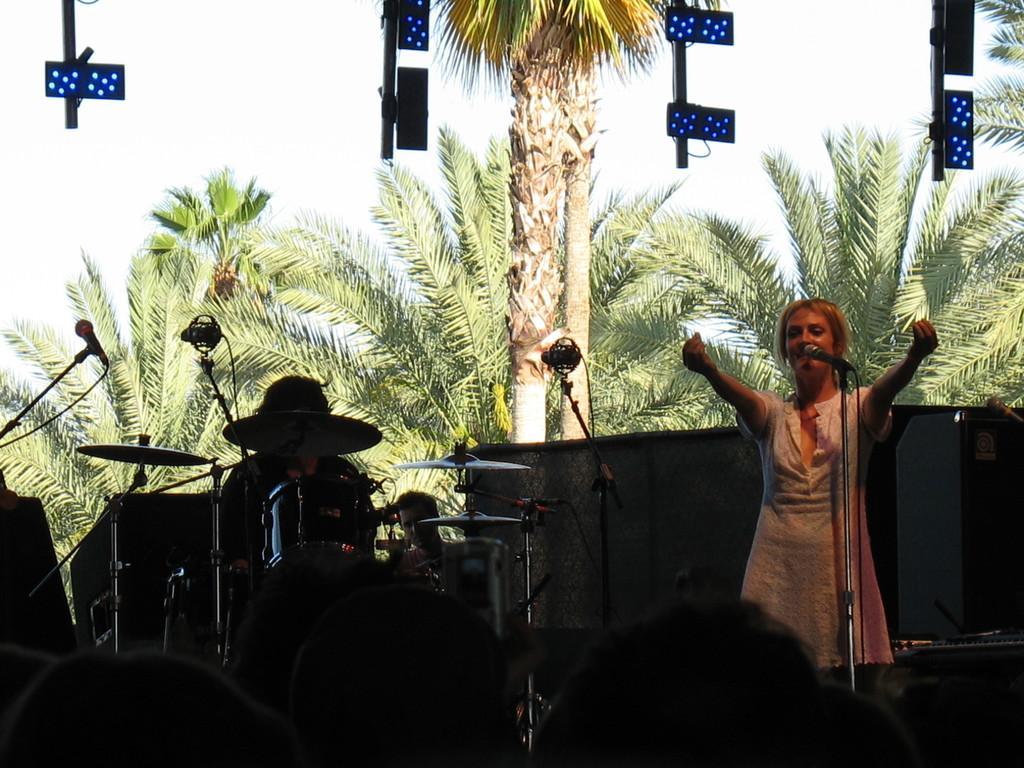In one or two sentences, can you explain what this image depicts? In this image, I can see a person standing and there are two persons behind the drums. I can see the miles with the mike stands. In the background, there are trees and I can see the sky. At the top of the image, I can see the lights. 